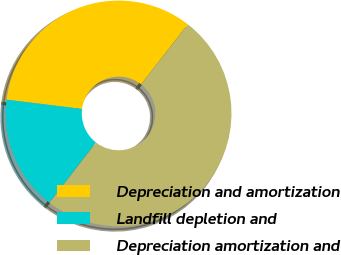Convert chart. <chart><loc_0><loc_0><loc_500><loc_500><pie_chart><fcel>Depreciation and amortization<fcel>Landfill depletion and<fcel>Depreciation amortization and<nl><fcel>33.56%<fcel>16.44%<fcel>50.0%<nl></chart> 